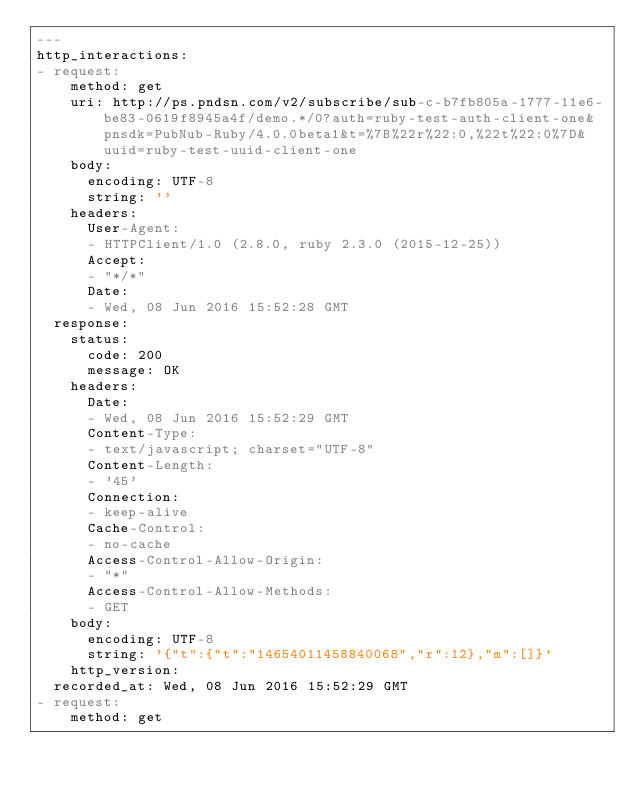Convert code to text. <code><loc_0><loc_0><loc_500><loc_500><_YAML_>---
http_interactions:
- request:
    method: get
    uri: http://ps.pndsn.com/v2/subscribe/sub-c-b7fb805a-1777-11e6-be83-0619f8945a4f/demo.*/0?auth=ruby-test-auth-client-one&pnsdk=PubNub-Ruby/4.0.0beta1&t=%7B%22r%22:0,%22t%22:0%7D&uuid=ruby-test-uuid-client-one
    body:
      encoding: UTF-8
      string: ''
    headers:
      User-Agent:
      - HTTPClient/1.0 (2.8.0, ruby 2.3.0 (2015-12-25))
      Accept:
      - "*/*"
      Date:
      - Wed, 08 Jun 2016 15:52:28 GMT
  response:
    status:
      code: 200
      message: OK
    headers:
      Date:
      - Wed, 08 Jun 2016 15:52:29 GMT
      Content-Type:
      - text/javascript; charset="UTF-8"
      Content-Length:
      - '45'
      Connection:
      - keep-alive
      Cache-Control:
      - no-cache
      Access-Control-Allow-Origin:
      - "*"
      Access-Control-Allow-Methods:
      - GET
    body:
      encoding: UTF-8
      string: '{"t":{"t":"14654011458840068","r":12},"m":[]}'
    http_version: 
  recorded_at: Wed, 08 Jun 2016 15:52:29 GMT
- request:
    method: get</code> 